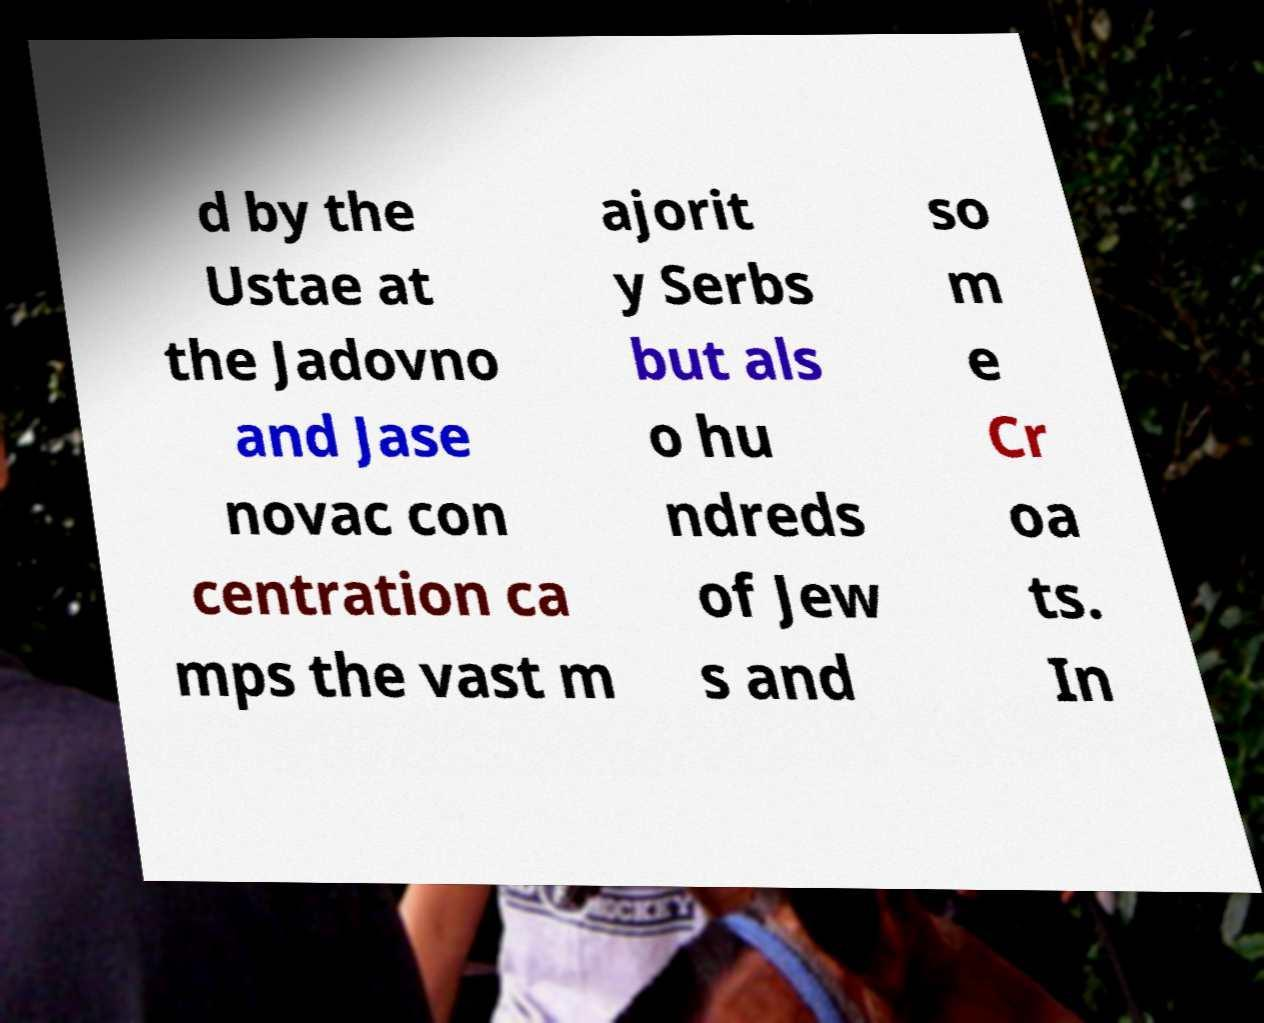Please identify and transcribe the text found in this image. d by the Ustae at the Jadovno and Jase novac con centration ca mps the vast m ajorit y Serbs but als o hu ndreds of Jew s and so m e Cr oa ts. In 